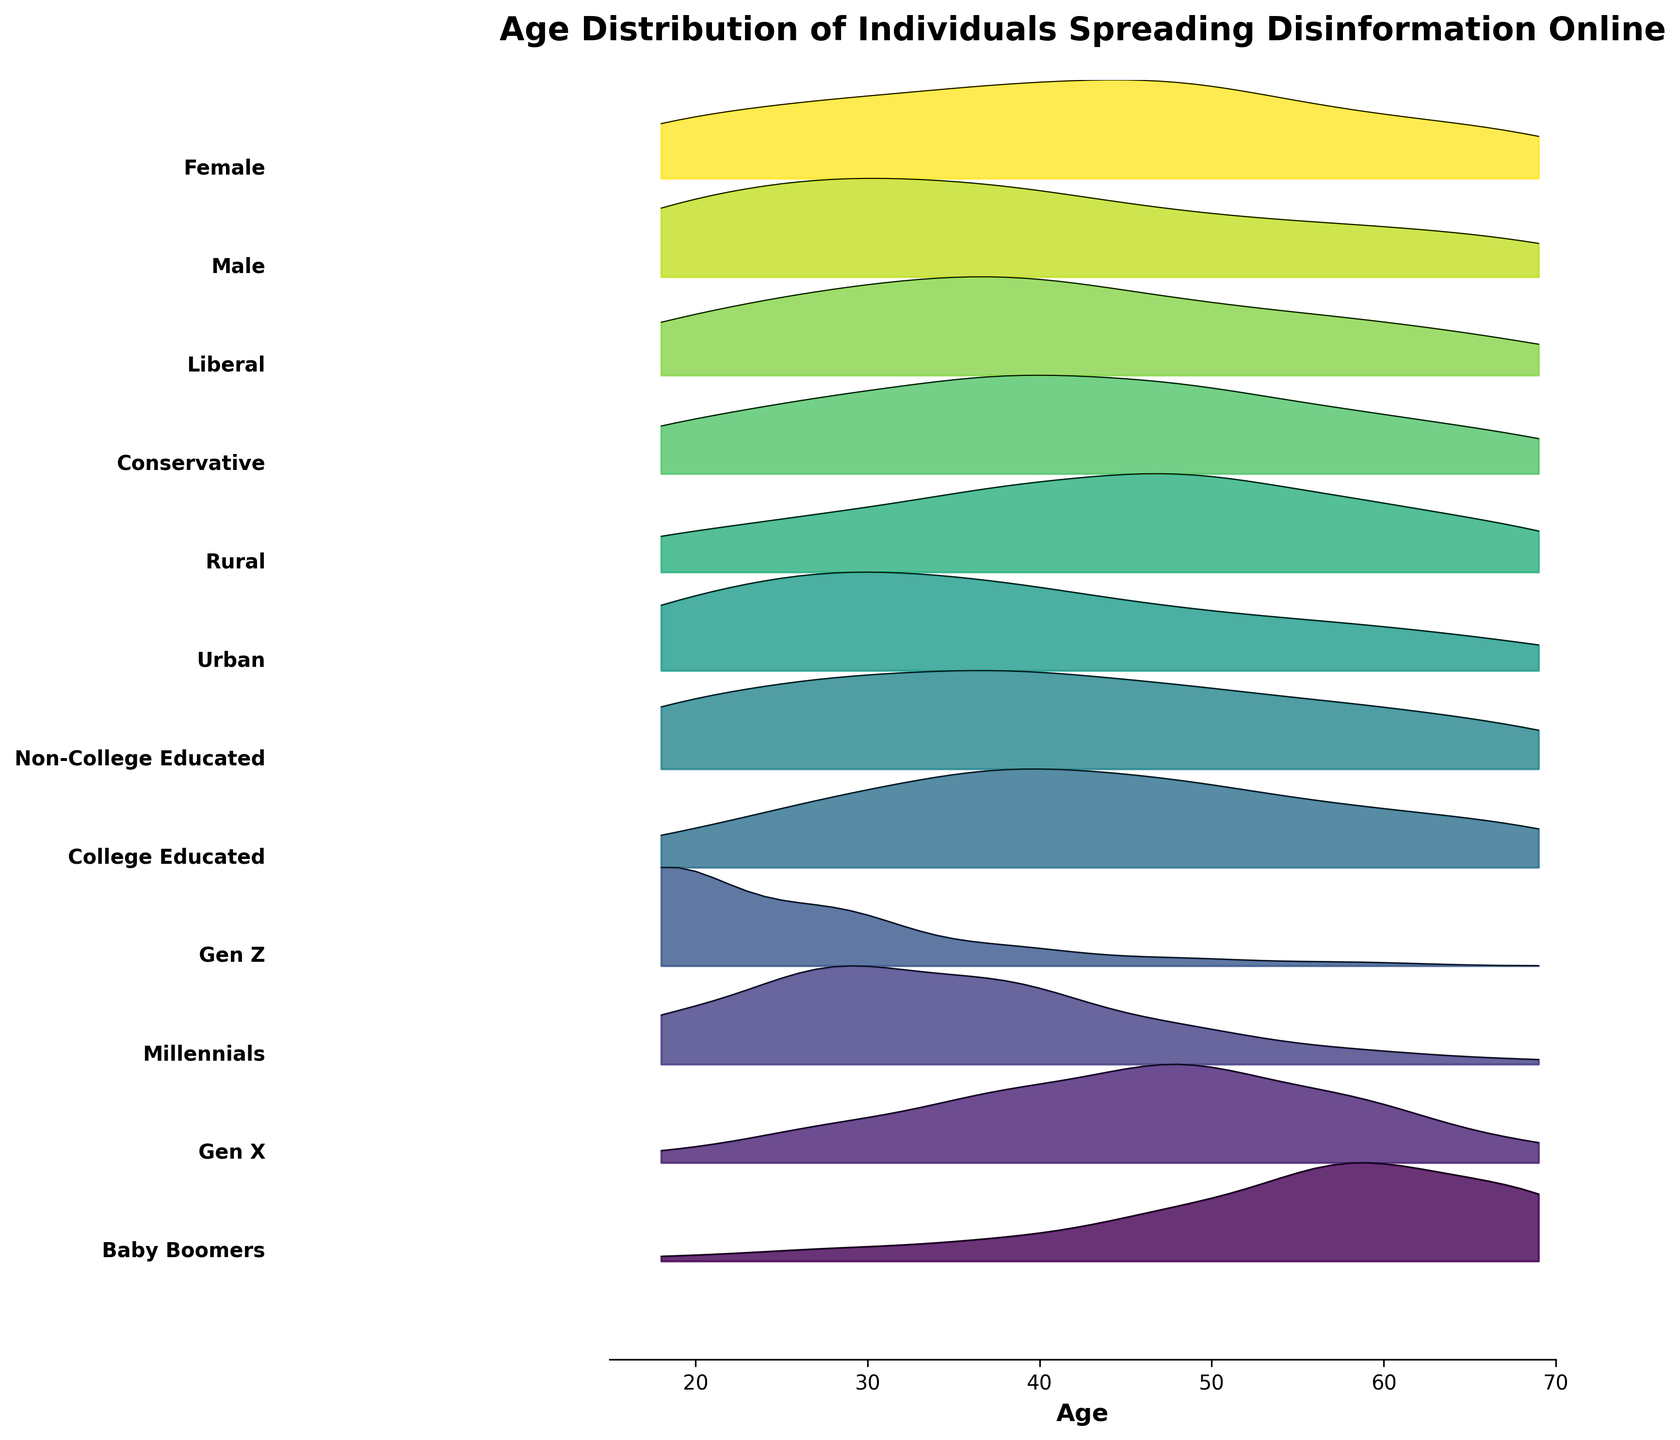What is the title of the plot? The title is displayed on top of the plot, revealing the main subject of the visual representation.
Answer: Age Distribution of Individuals Spreading Disinformation Online How many demographic groups are represented in the plot? Count the number of different categories listed on the y-axis.
Answer: 12 Which demographic group has the highest density of individuals in the age range of 18-24? Look at the ridgeline plots and identify which one peaks highest between the ages of 18-24.
Answer: Gen Z Which group shows a more even distribution across all age ranges: Urban or Rural? Compare the ridgeline plots of Urban and Rural to see which has fewer pronounced peaks and valleys.
Answer: Rural Between Gen X and Baby Boomers, which group has more individuals spreading disinformation in the 45-54 age range? Compare the heights of the ridgeline plots for Gen X and Baby Boomers in the 45-54 age range.
Answer: Baby Boomers How does the age distribution for College Educated individuals compare to Non-College Educated individuals? Examine the contours of the ridgeline plots for both groups to note differences in peaks and troughs across different age ranges.
Answer: Non-College Educated have higher peaks across most age ranges Which group peaks later in age range: Male or Female? Compare the points where the ridgeline plots for Male and Female reach their highest values.
Answer: Female Is the peak age range for Millennials higher or lower than that for Baby Boomers? Compare the highest points of the ridgeline plots for Millennials and Baby Boomers.
Answer: Lower What age range has the highest density for Conservative individuals? Look for the highest peak in the ridgeline plot for Conservatives and identify the corresponding age range.
Answer: 35-44 Are there more individuals in the age range of 55-64 in the category "Liberal" or "Conservative"? Compare the heights of the ridgeline plots for Liberals and Conservatives in the 55-64 age range.
Answer: Conservative 